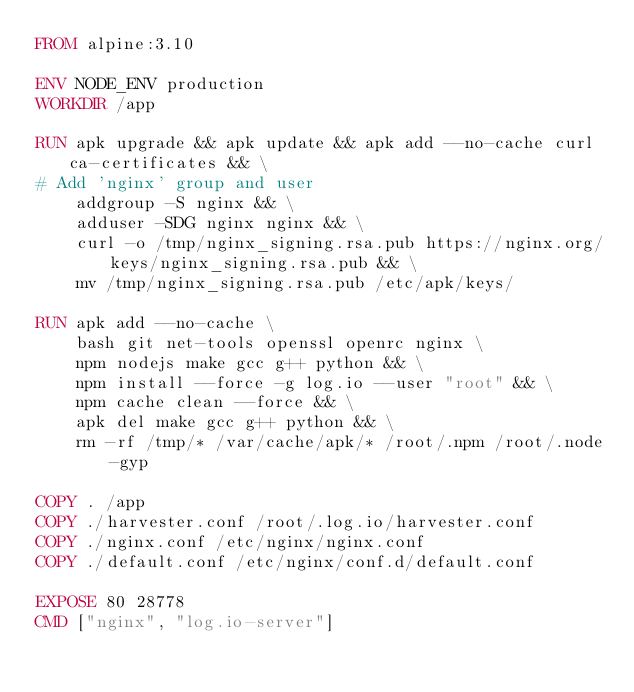Convert code to text. <code><loc_0><loc_0><loc_500><loc_500><_Dockerfile_>FROM alpine:3.10

ENV NODE_ENV production
WORKDIR /app

RUN apk upgrade && apk update && apk add --no-cache curl ca-certificates && \
# Add 'nginx' group and user
    addgroup -S nginx && \
    adduser -SDG nginx nginx && \
    curl -o /tmp/nginx_signing.rsa.pub https://nginx.org/keys/nginx_signing.rsa.pub && \
    mv /tmp/nginx_signing.rsa.pub /etc/apk/keys/

RUN apk add --no-cache \
    bash git net-tools openssl openrc nginx \
    npm nodejs make gcc g++ python && \
    npm install --force -g log.io --user "root" && \
    npm cache clean --force && \
    apk del make gcc g++ python && \
    rm -rf /tmp/* /var/cache/apk/* /root/.npm /root/.node-gyp

COPY . /app
COPY ./harvester.conf /root/.log.io/harvester.conf
COPY ./nginx.conf /etc/nginx/nginx.conf
COPY ./default.conf /etc/nginx/conf.d/default.conf

EXPOSE 80 28778
CMD ["nginx", "log.io-server"]
</code> 